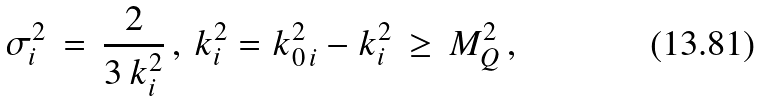<formula> <loc_0><loc_0><loc_500><loc_500>\sigma _ { i } ^ { 2 } \, = \, \frac { 2 } { 3 \, k _ { i } ^ { 2 } } \, , \, k _ { i } ^ { 2 } = k _ { 0 \, i } ^ { 2 } - { k } _ { i } ^ { 2 } \, \geq \, M _ { Q } ^ { 2 } \, ,</formula> 